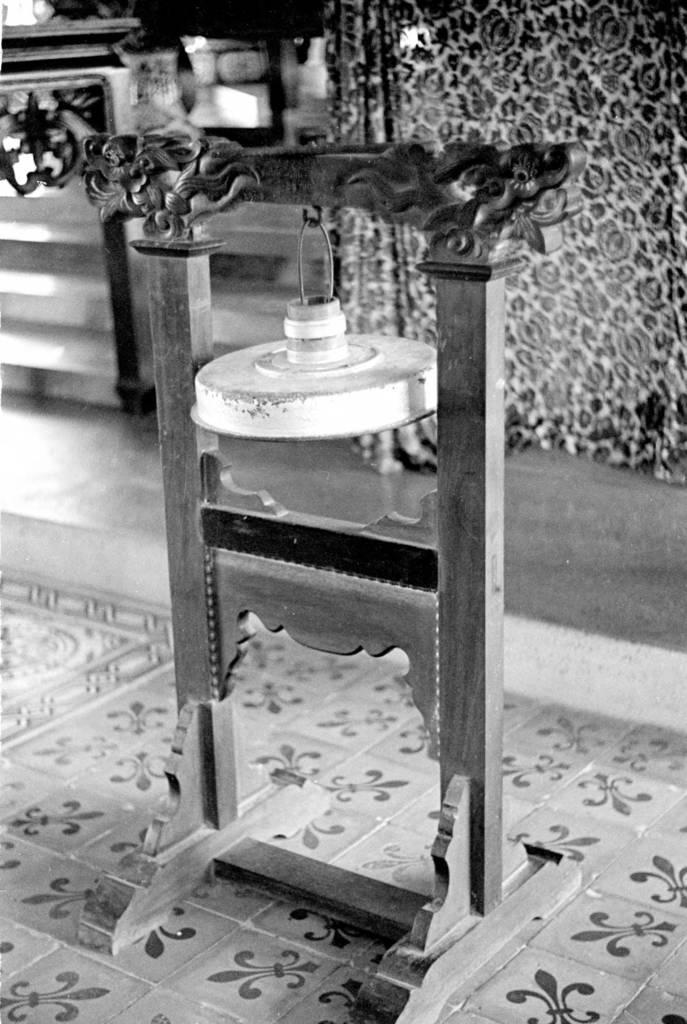What is the color scheme of the image? The image is black and white. What can be seen on the floor in the image? There is a wooden stand on the floor in the image. What is the wooden stand supporting? Something is hanged on the wooden stand. What type of rings can be seen on the field in the image? There is no field or rings present in the image; it features a black and white image with a wooden stand on the floor. 